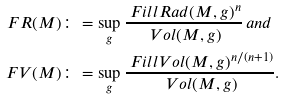<formula> <loc_0><loc_0><loc_500><loc_500>\ F R ( M ) & \colon = \sup _ { g } \frac { \ F i l l R a d ( M , g ) ^ { n } } { \ V o l ( M , g ) } \, a n d \\ \ F V ( M ) & \colon = \sup _ { g } \frac { \ F i l l V o l ( M , g ) ^ { n / ( n + 1 ) } } { \ V o l ( M , g ) } .</formula> 